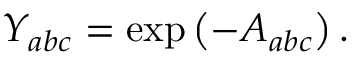<formula> <loc_0><loc_0><loc_500><loc_500>Y _ { a b c } = \exp \left ( - A _ { a b c } \right ) .</formula> 